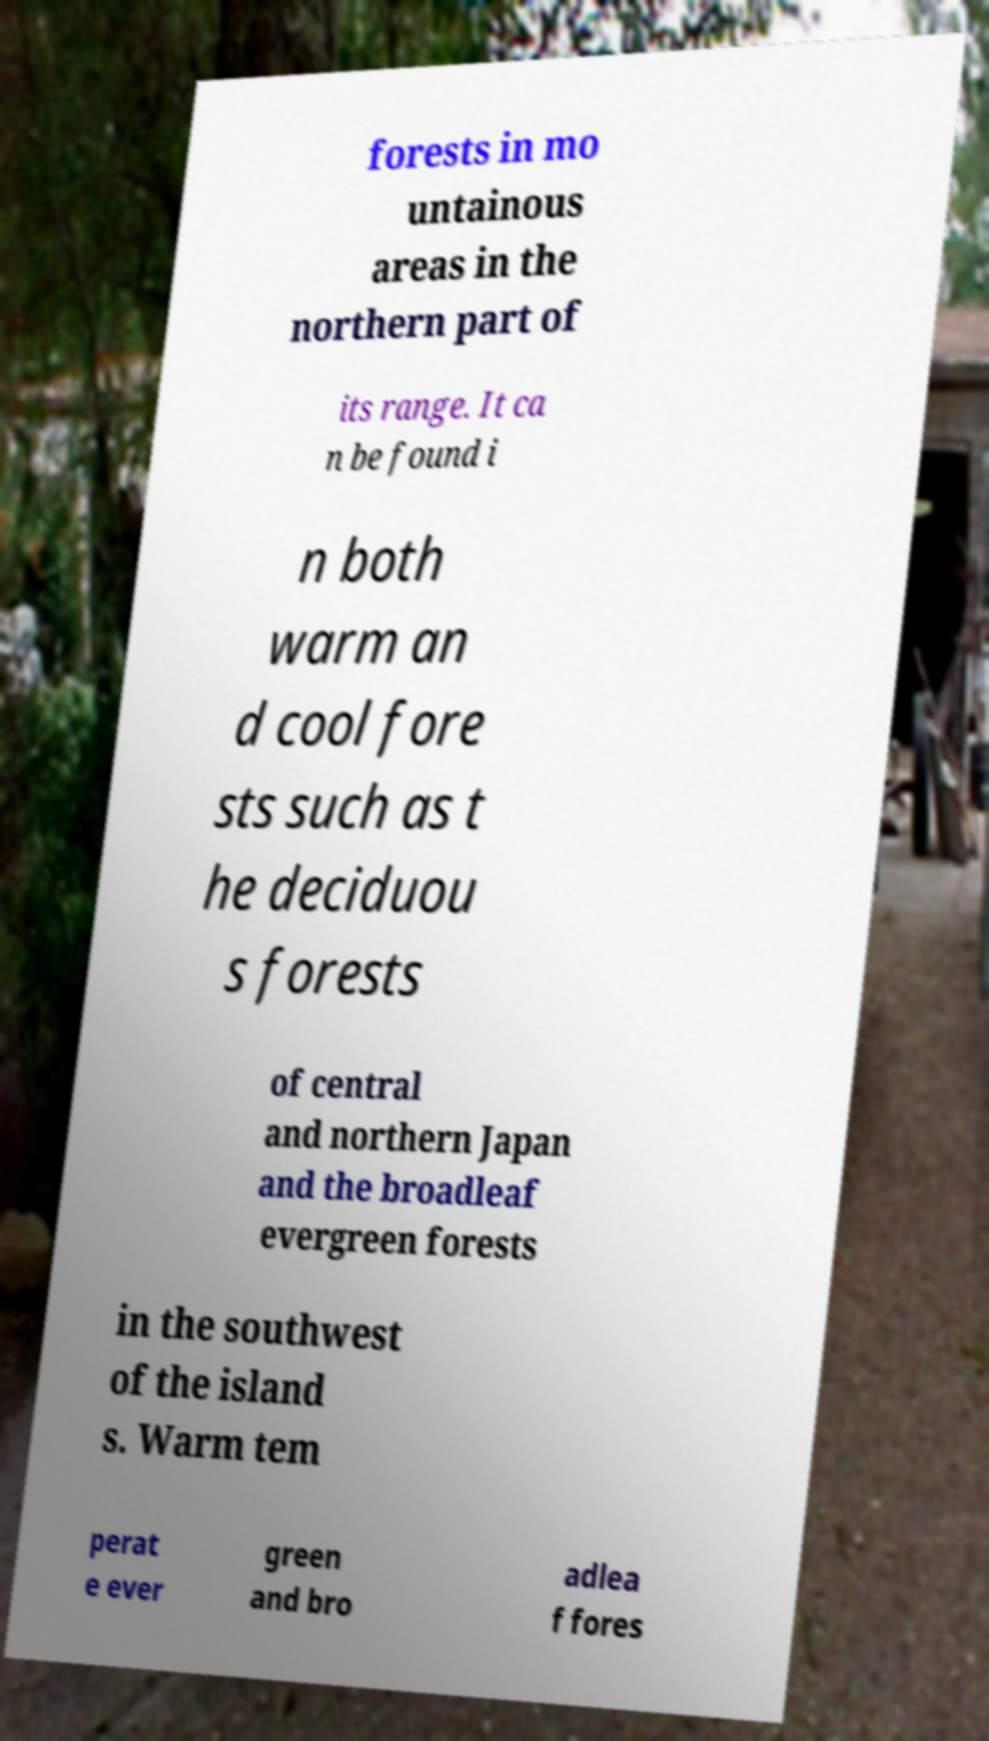Could you extract and type out the text from this image? forests in mo untainous areas in the northern part of its range. It ca n be found i n both warm an d cool fore sts such as t he deciduou s forests of central and northern Japan and the broadleaf evergreen forests in the southwest of the island s. Warm tem perat e ever green and bro adlea f fores 